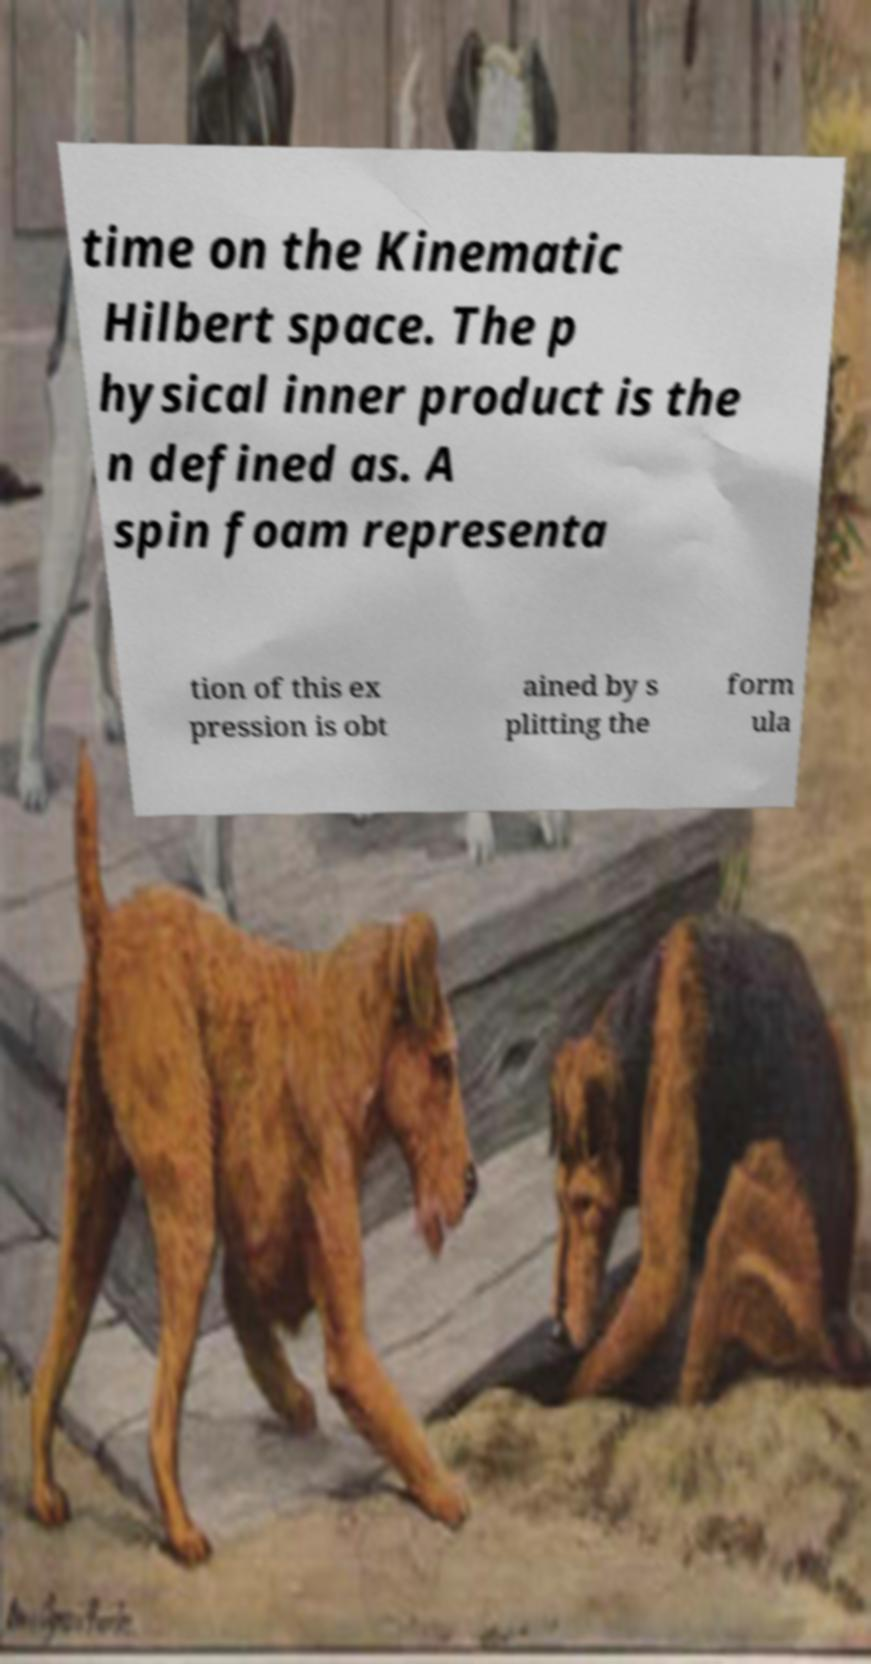For documentation purposes, I need the text within this image transcribed. Could you provide that? time on the Kinematic Hilbert space. The p hysical inner product is the n defined as. A spin foam representa tion of this ex pression is obt ained by s plitting the form ula 